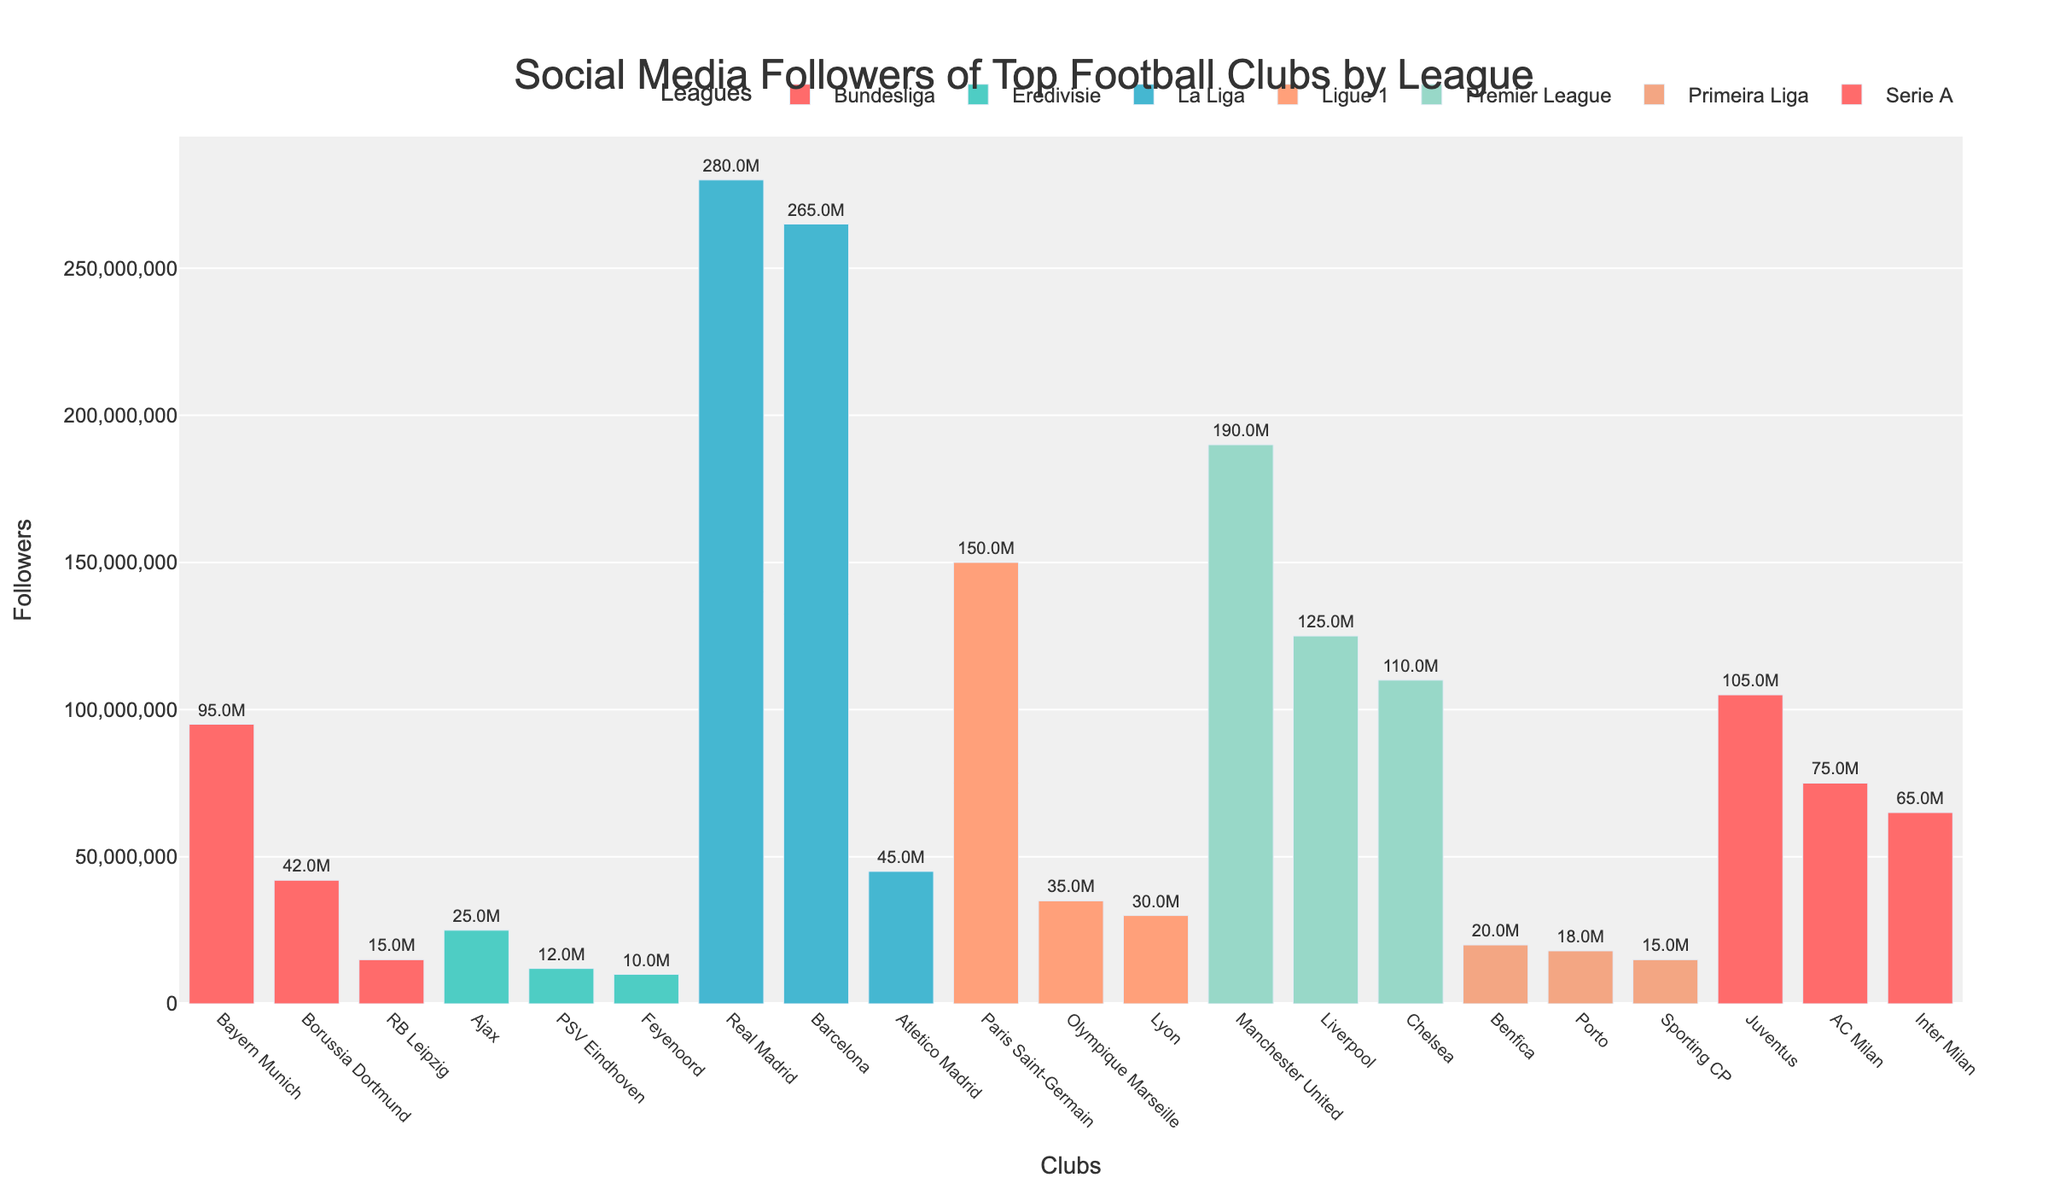Which league has the club with the most followers? To find this, look for the highest bar in the figure and identify its associated league. The club with the most followers is Real Madrid from La Liga.
Answer: La Liga What are the three clubs with the highest follower counts? Identify the three tallest bars in the figure and note their respective clubs. These are Real Madrid, Barcelona, and Manchester United.
Answer: Real Madrid, Barcelona, Manchester United How many followers separate Manchester United and Bayern Munich? Find the follower count for Manchester United (190,000,000) and Bayern Munich (95,000,000). Subtract Bayern Munich's followers from Manchester United's followers: 190,000,000 - 95,000,000 = 95,000,000
Answer: 95,000,000 Which club in the Premier League has the least followers? Locate the lowest bar within the Premier League grouping. Chelsea has the lowest follower count at 110,000,000.
Answer: Chelsea How many clubs from Serie A are included in the plot? Count the number of bars associated with Serie A in the figure. There are three clubs: Juventus, AC Milan, and Inter Milan.
Answer: Three What is the average number of followers for the clubs in Ligue 1? Add the follower counts for Paris Saint-Germain (150,000,000), Olympique Marseille (35,000,000), and Lyon (30,000,000). Divide the sum by 3: (150,000,000 + 35,000,000 + 30,000,000) / 3 = 71,666,667
Answer: 71,666,667 Which club has more followers, Borussia Dortmund or Atletico Madrid? Compare the heights of the bars for Borussia Dortmund (42,000,000) and Atletico Madrid (45,000,000). Atletico Madrid has more followers.
Answer: Atletico Madrid What is the follower count difference between the top club in Eredivisie and the top club in Primeira Liga? Identify the top clubs in Eredivisie (Ajax, 25,000,000) and Primeira Liga (Benfica, 20,000,000). Subtract Benfica's followers from Ajax's: 25,000,000 - 20,000,000 = 5,000,000
Answer: 5,000,000 Which league has the most clubs with over 100 million followers each? Look through the figure to identify leagues and their clubs with follower counts over 100 million. The Premier League has three clubs (Manchester United, Liverpool, and Chelsea).
Answer: Premier League 